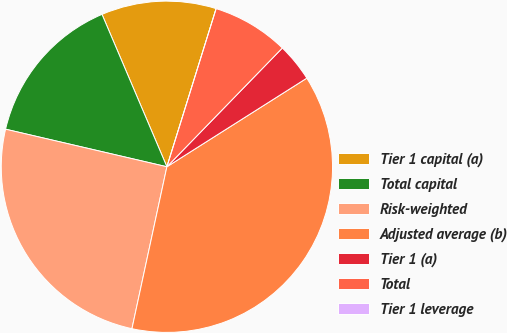Convert chart to OTSL. <chart><loc_0><loc_0><loc_500><loc_500><pie_chart><fcel>Tier 1 capital (a)<fcel>Total capital<fcel>Risk-weighted<fcel>Adjusted average (b)<fcel>Tier 1 (a)<fcel>Total<fcel>Tier 1 leverage<nl><fcel>11.21%<fcel>14.95%<fcel>25.26%<fcel>37.37%<fcel>3.74%<fcel>7.47%<fcel>0.0%<nl></chart> 